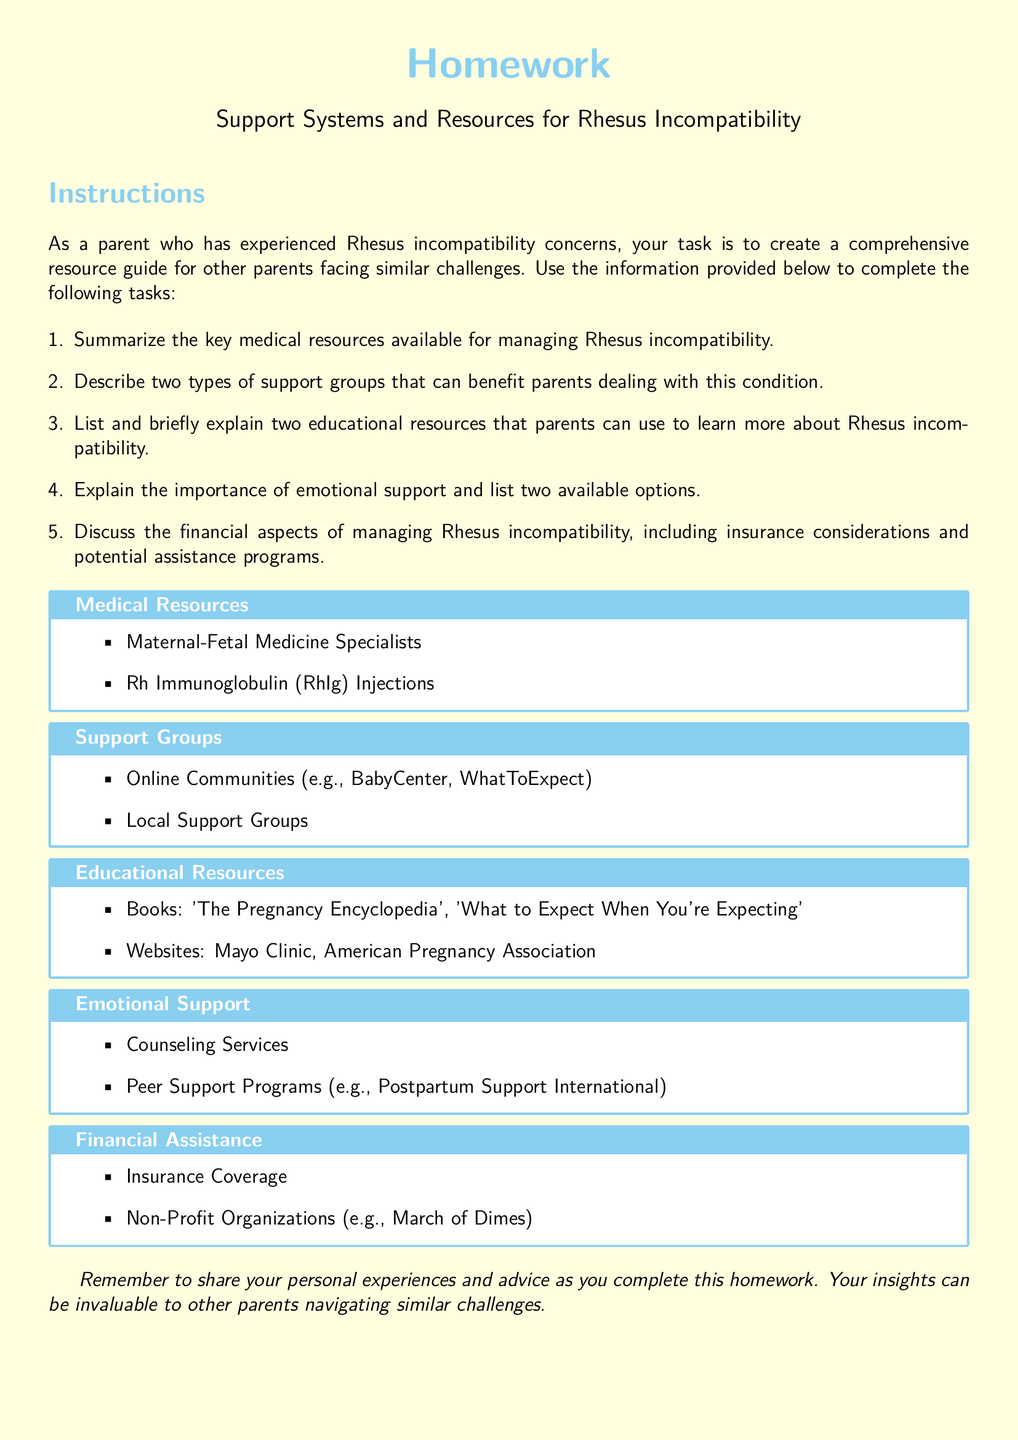what are two types of support groups listed? The document mentions Online Communities and Local Support Groups as the two types of support groups beneficial for parents.
Answer: Online Communities, Local Support Groups how many medical resources are mentioned? The document lists two medical resources available for managing Rhesus incompatibility.
Answer: 2 what emotional support options are provided? The document includes Counseling Services and Peer Support Programs as options for emotional support.
Answer: Counseling Services, Peer Support Programs what is the name of a recommended website for educational resources? The document lists Mayo Clinic as one of the recommended websites for parents to learn more about Rhesus incompatibility.
Answer: Mayo Clinic name one non-profit organization mentioned for financial assistance. The document refers to March of Dimes as a non-profit organization that can provide financial assistance.
Answer: March of Dimes what type of homework task is outlined in the document? The document outlines various tasks for creating a comprehensive resource guide for parents facing Rhesus incompatibility concerns.
Answer: comprehensive resource guide what does Rh stand for in Rh Immunoglobulin? The abbreviation "Rh" refers to Rhesus, which is associated with the incompatibility concerns mentioned in the context.
Answer: Rhesus how many educational resources types are mentioned? The document mentions two types of educational resources available for parents to learn more about Rhesus incompatibility.
Answer: 2 